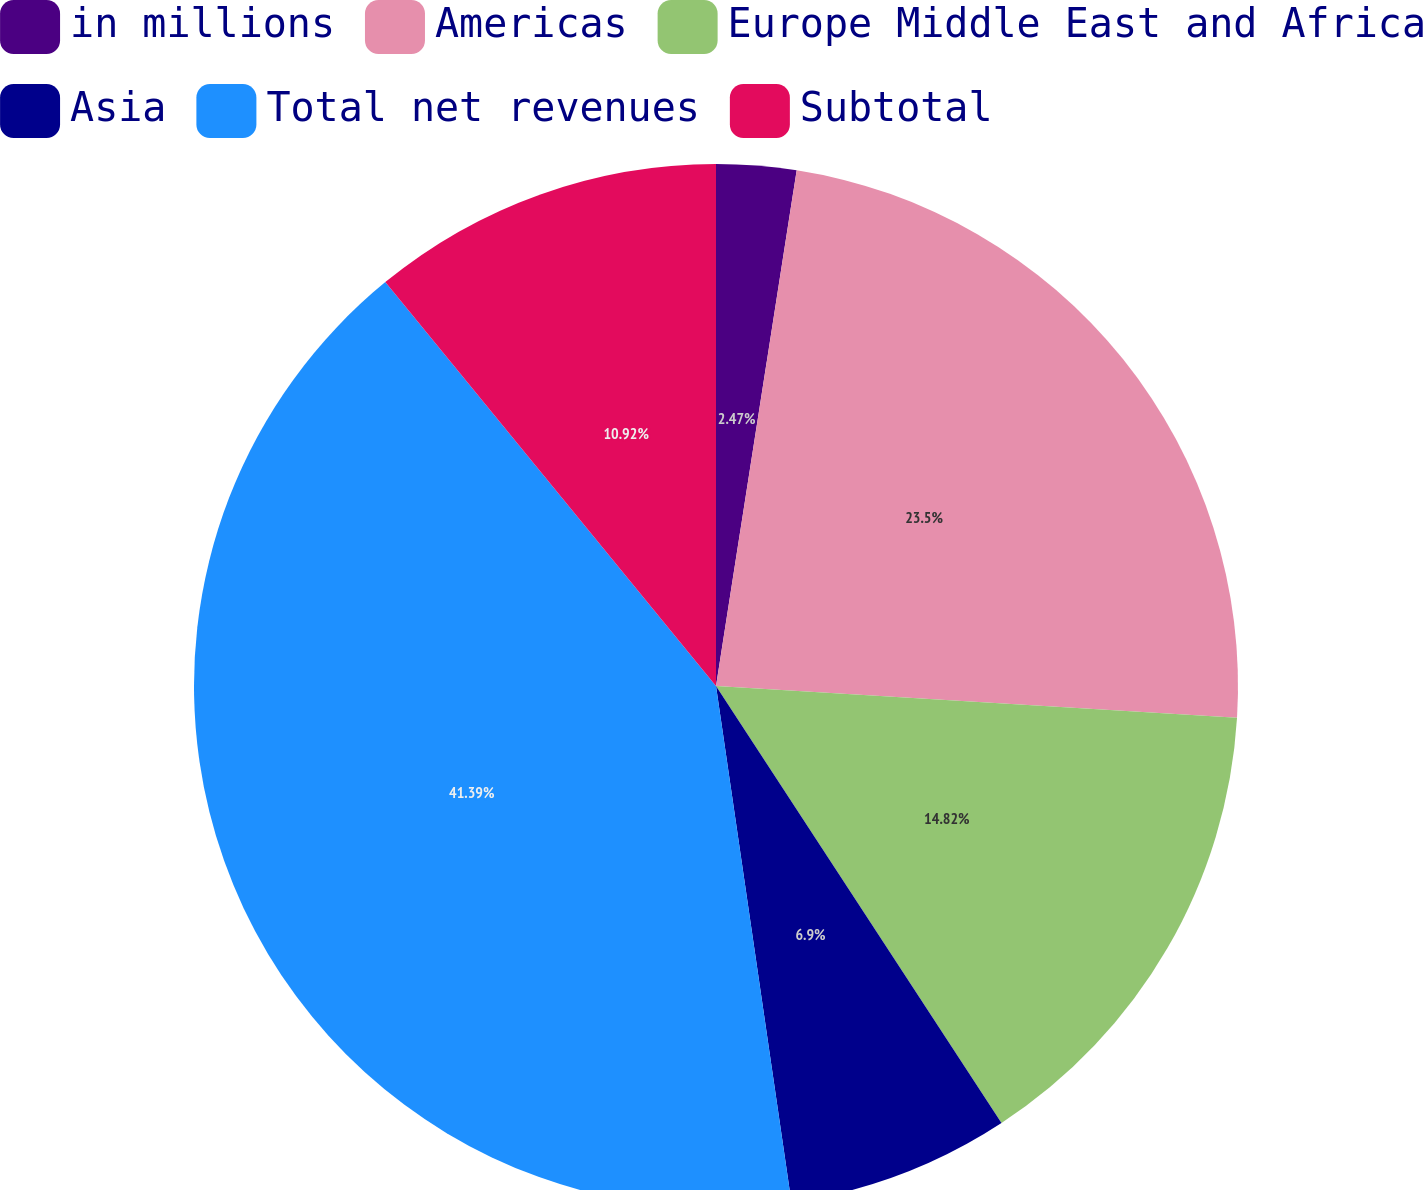<chart> <loc_0><loc_0><loc_500><loc_500><pie_chart><fcel>in millions<fcel>Americas<fcel>Europe Middle East and Africa<fcel>Asia<fcel>Total net revenues<fcel>Subtotal<nl><fcel>2.47%<fcel>23.5%<fcel>14.82%<fcel>6.9%<fcel>41.39%<fcel>10.92%<nl></chart> 